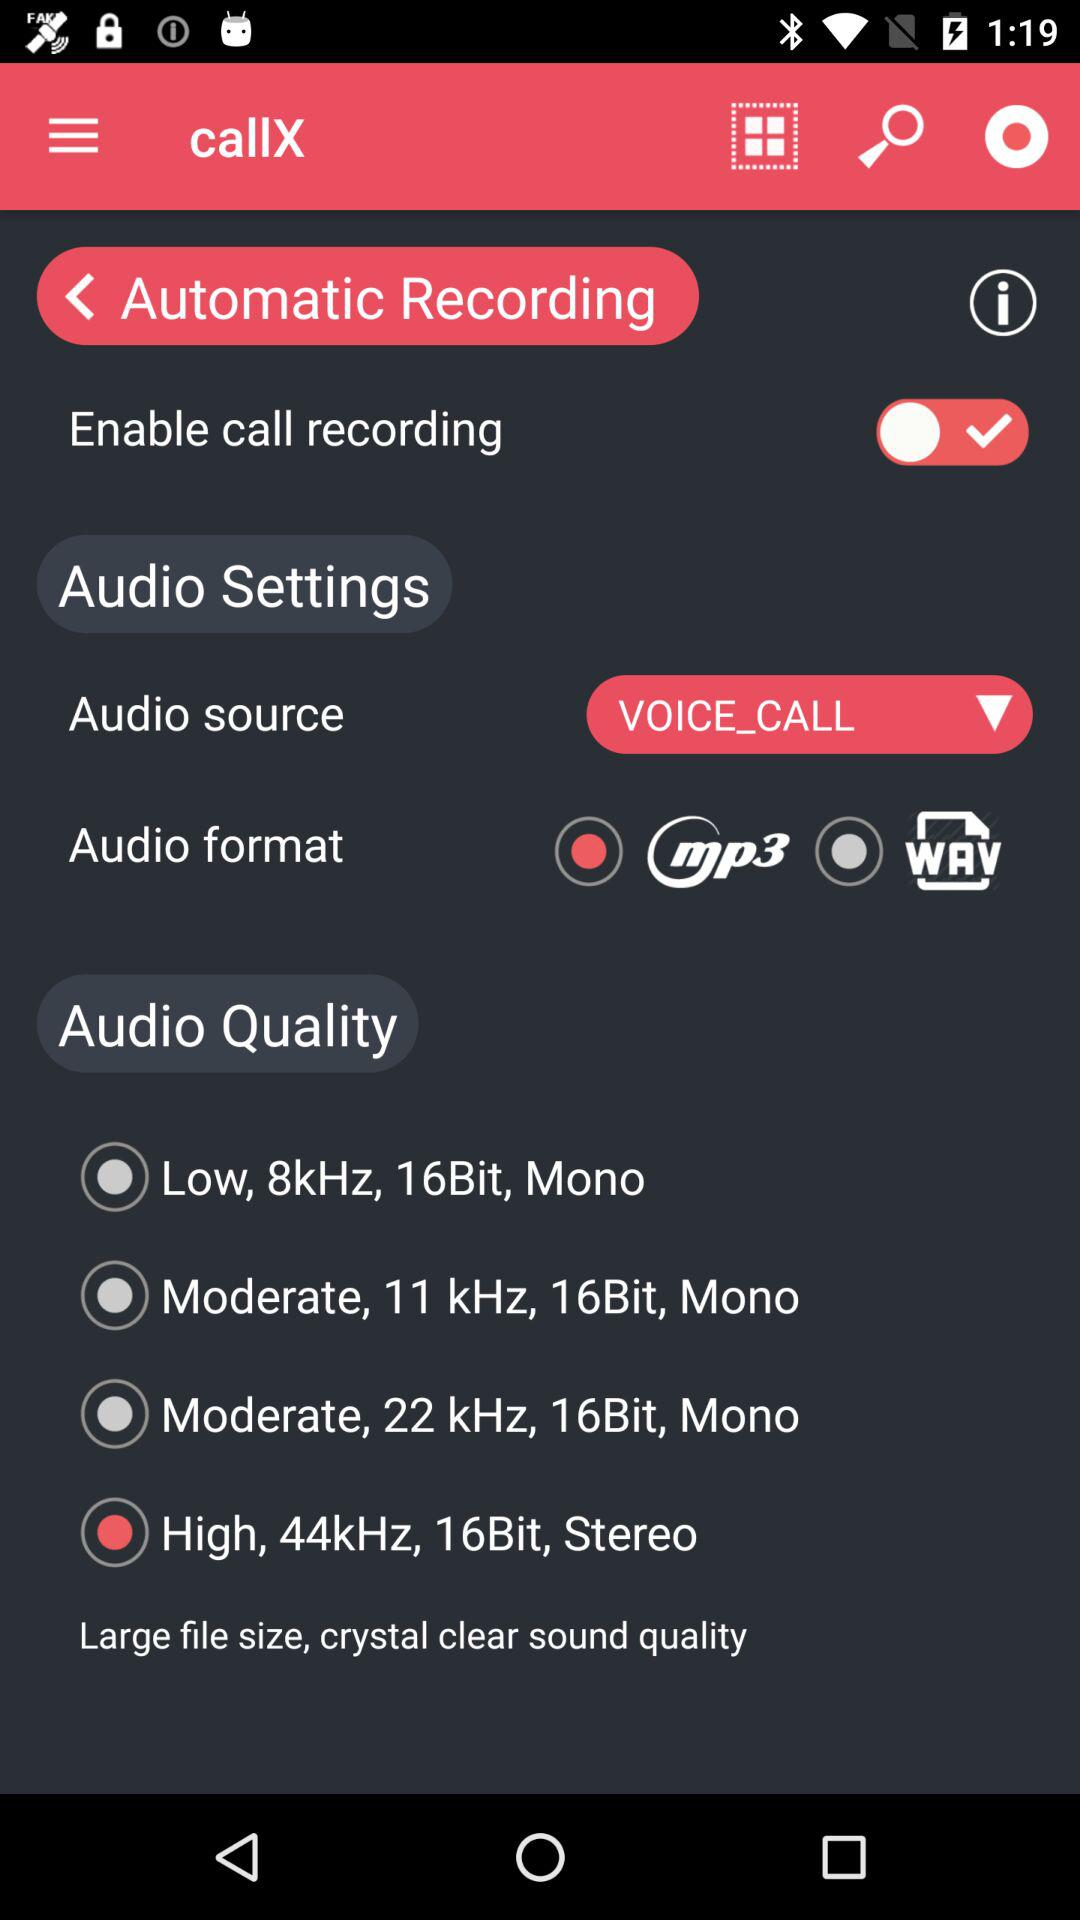Which audio format is selected? The selected audio format is mp3. 